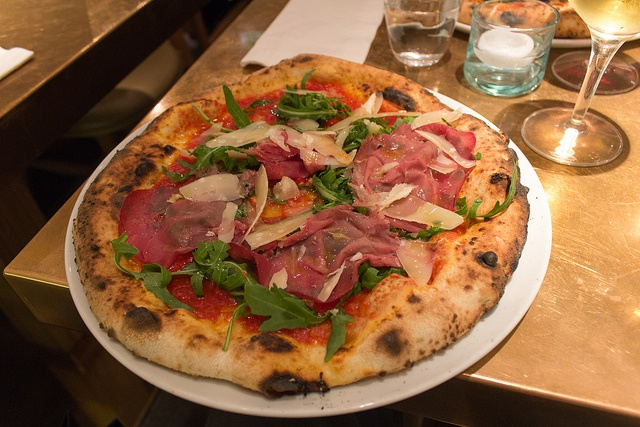Describe the objects in this image and their specific colors. I can see pizza in tan, brown, maroon, and olive tones, dining table in tan, black, brown, and maroon tones, wine glass in tan, khaki, brown, and ivory tones, cup in tan, lightgray, and gray tones, and cup in tan, maroon, gray, and brown tones in this image. 